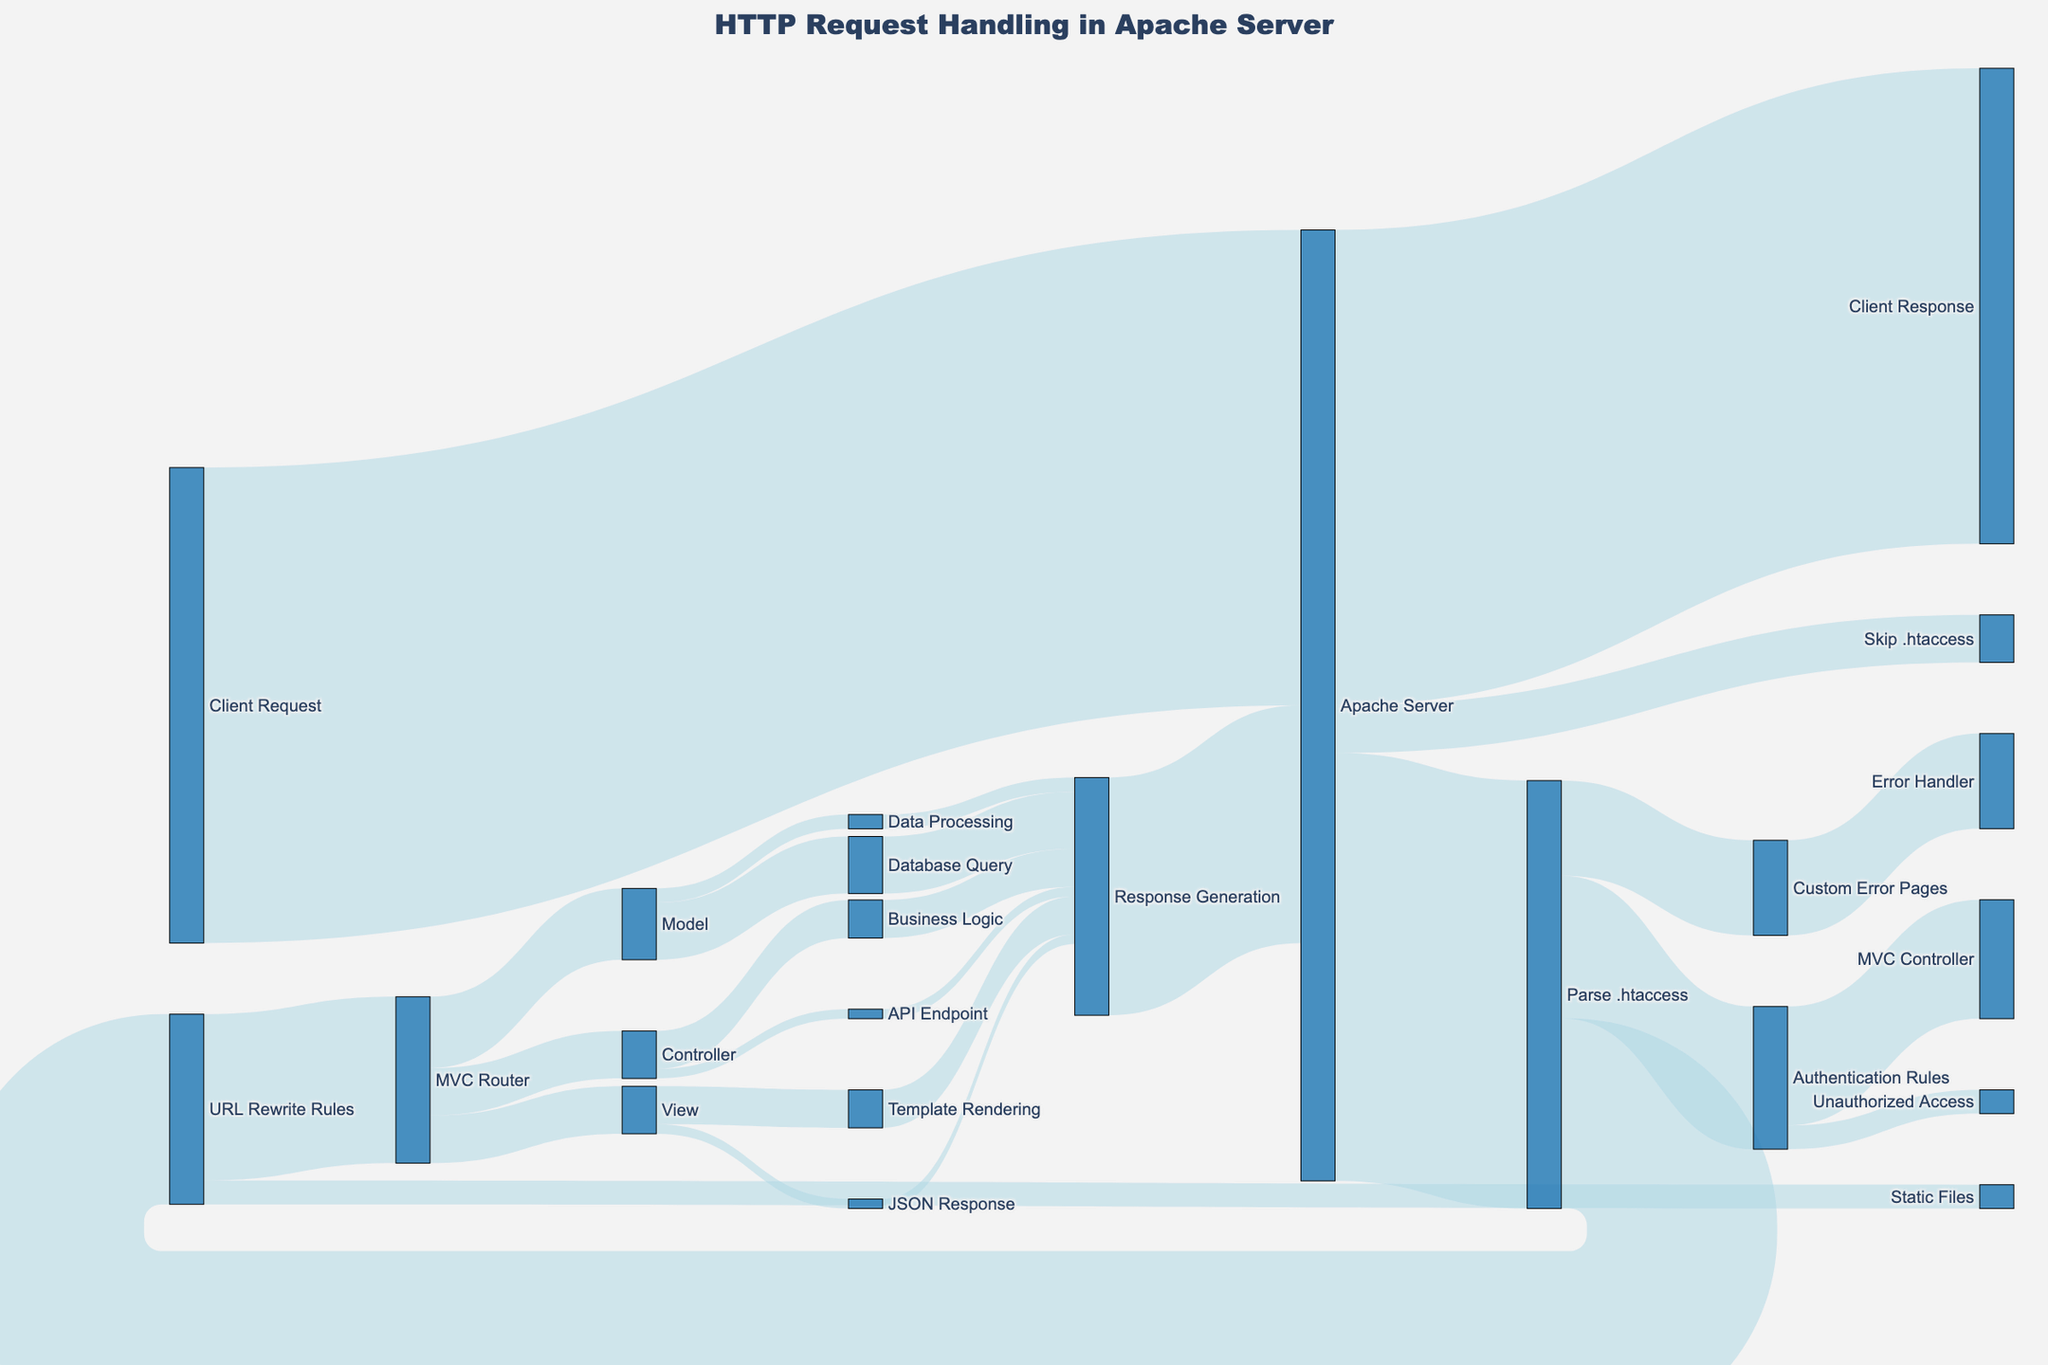What is the title of the figure? The title of the figure is mentioned at the top and describes the overall subject of the diagram. It reads "HTTP Request Handling in Apache Server."
Answer: HTTP Request Handling in Apache Server How many total requests are parsed by the .htaccess file? By looking at the flows from the "Apache Server" node, we see that 90 requests go to "Parse .htaccess."
Answer: 90 How many requests are handled by URL Rewrite Rules after being processed by the .htaccess file? From the "Parse .htaccess" node, we see 40 requests are directed to the "URL Rewrite Rules" node.
Answer: 40 Which process handles the least amount of HTTP requests after .htaccess parsing, and how many does it handle? Out of the routes from "Parse .htaccess," the "Custom Error Pages" node handles the least with 20 HTTP requests.
Answer: Custom Error Pages, 20 How many requests are directly skipped to Apache Server without parsing .htaccess? From the "Apache Server" node, we see that "Skip .htaccess" handles 10 requests.
Answer: 10 How many HTTP requests eventually lead to Response Generation? Adding up the values reaching the "Response Generation" node (12 + 3 + 8 + 2 + 8 + 2) yields a total of 35 requests, but considering each source’s contribution to avoid double counting, it simplifies to 35.
Answer: 35 Which node receives the highest number of HTTP requests directly from the Apache Server? The "Parse .htaccess" node receives 90 HTTP requests, which is the highest among its direct outputs.
Answer: Parse .htaccess How many requests reach the Model after going through the MVC Router? From the "MVC Router" node, 15 requests are directed to the "Model" node.
Answer: 15 Are there more requests handled by Authentication Rules or URL Rewrite Rules after parsing the .htaccess? Authentication Rules handle 30 requests, while URL Rewrite Rules handle 40. Therefore, URL Rewrite Rules handle more requests.
Answer: URL Rewrite Rules What sum of requests move from both URL Rewrite Rules and Authentication Rules to MVC Router and MVC Controller, excluding static files and unauthorized access? MVC Router handles 35 requests from URL Rewrite Rules, and MVC Controller handles 25 from Authentication Rules, summing up to 60. Excluding 5 for static files and 5 for unauthorized access.
Answer: 60 